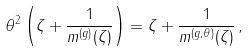<formula> <loc_0><loc_0><loc_500><loc_500>\theta ^ { 2 } \left ( \zeta + \frac { 1 } { m ^ { ( g ) } ( \zeta ) } \right ) = \zeta + \frac { 1 } { m ^ { ( g , \theta ) } ( \zeta ) } \, ,</formula> 